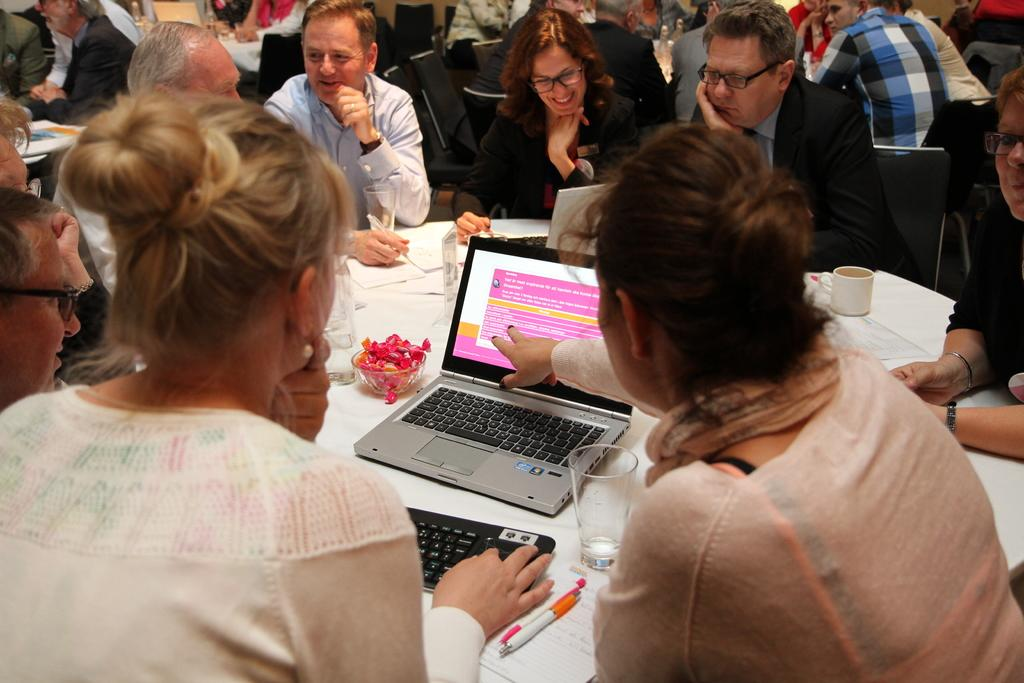What are the people in the image doing? There is a group of people sitting on chairs in the image. What is on the table in the image? There is a table in the image, and laptops and cups are visible on the table. What is covering the table? There is a white color cloth covering the table. Are there any other objects on the table besides laptops and cups? Yes, there are other objects on the table. What type of powder is being used to make pies in the image? There is no powder or pies present in the image; it features a group of people sitting on chairs around a table with laptops, cups, and other objects. Can you see a rifle on the table in the image? No, there is no rifle present in the image. 